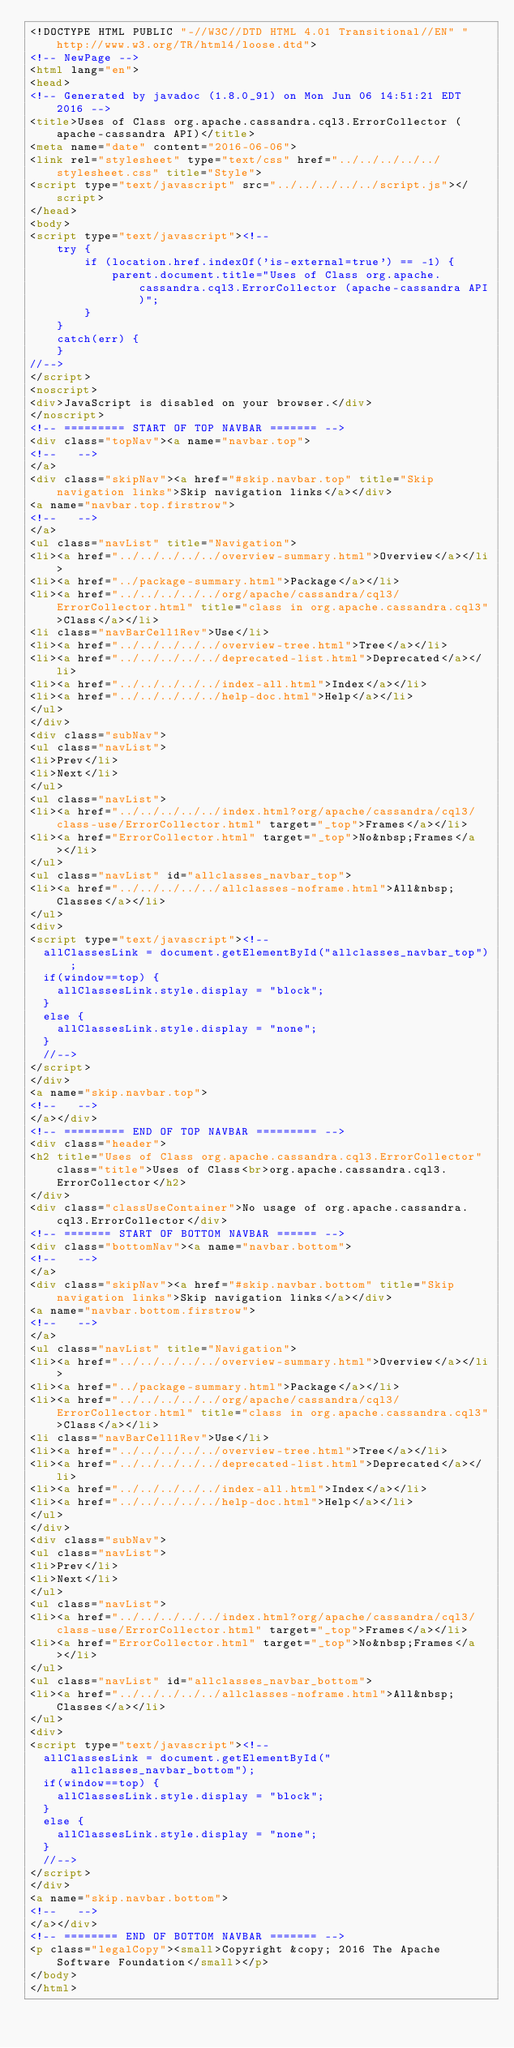Convert code to text. <code><loc_0><loc_0><loc_500><loc_500><_HTML_><!DOCTYPE HTML PUBLIC "-//W3C//DTD HTML 4.01 Transitional//EN" "http://www.w3.org/TR/html4/loose.dtd">
<!-- NewPage -->
<html lang="en">
<head>
<!-- Generated by javadoc (1.8.0_91) on Mon Jun 06 14:51:21 EDT 2016 -->
<title>Uses of Class org.apache.cassandra.cql3.ErrorCollector (apache-cassandra API)</title>
<meta name="date" content="2016-06-06">
<link rel="stylesheet" type="text/css" href="../../../../../stylesheet.css" title="Style">
<script type="text/javascript" src="../../../../../script.js"></script>
</head>
<body>
<script type="text/javascript"><!--
    try {
        if (location.href.indexOf('is-external=true') == -1) {
            parent.document.title="Uses of Class org.apache.cassandra.cql3.ErrorCollector (apache-cassandra API)";
        }
    }
    catch(err) {
    }
//-->
</script>
<noscript>
<div>JavaScript is disabled on your browser.</div>
</noscript>
<!-- ========= START OF TOP NAVBAR ======= -->
<div class="topNav"><a name="navbar.top">
<!--   -->
</a>
<div class="skipNav"><a href="#skip.navbar.top" title="Skip navigation links">Skip navigation links</a></div>
<a name="navbar.top.firstrow">
<!--   -->
</a>
<ul class="navList" title="Navigation">
<li><a href="../../../../../overview-summary.html">Overview</a></li>
<li><a href="../package-summary.html">Package</a></li>
<li><a href="../../../../../org/apache/cassandra/cql3/ErrorCollector.html" title="class in org.apache.cassandra.cql3">Class</a></li>
<li class="navBarCell1Rev">Use</li>
<li><a href="../../../../../overview-tree.html">Tree</a></li>
<li><a href="../../../../../deprecated-list.html">Deprecated</a></li>
<li><a href="../../../../../index-all.html">Index</a></li>
<li><a href="../../../../../help-doc.html">Help</a></li>
</ul>
</div>
<div class="subNav">
<ul class="navList">
<li>Prev</li>
<li>Next</li>
</ul>
<ul class="navList">
<li><a href="../../../../../index.html?org/apache/cassandra/cql3/class-use/ErrorCollector.html" target="_top">Frames</a></li>
<li><a href="ErrorCollector.html" target="_top">No&nbsp;Frames</a></li>
</ul>
<ul class="navList" id="allclasses_navbar_top">
<li><a href="../../../../../allclasses-noframe.html">All&nbsp;Classes</a></li>
</ul>
<div>
<script type="text/javascript"><!--
  allClassesLink = document.getElementById("allclasses_navbar_top");
  if(window==top) {
    allClassesLink.style.display = "block";
  }
  else {
    allClassesLink.style.display = "none";
  }
  //-->
</script>
</div>
<a name="skip.navbar.top">
<!--   -->
</a></div>
<!-- ========= END OF TOP NAVBAR ========= -->
<div class="header">
<h2 title="Uses of Class org.apache.cassandra.cql3.ErrorCollector" class="title">Uses of Class<br>org.apache.cassandra.cql3.ErrorCollector</h2>
</div>
<div class="classUseContainer">No usage of org.apache.cassandra.cql3.ErrorCollector</div>
<!-- ======= START OF BOTTOM NAVBAR ====== -->
<div class="bottomNav"><a name="navbar.bottom">
<!--   -->
</a>
<div class="skipNav"><a href="#skip.navbar.bottom" title="Skip navigation links">Skip navigation links</a></div>
<a name="navbar.bottom.firstrow">
<!--   -->
</a>
<ul class="navList" title="Navigation">
<li><a href="../../../../../overview-summary.html">Overview</a></li>
<li><a href="../package-summary.html">Package</a></li>
<li><a href="../../../../../org/apache/cassandra/cql3/ErrorCollector.html" title="class in org.apache.cassandra.cql3">Class</a></li>
<li class="navBarCell1Rev">Use</li>
<li><a href="../../../../../overview-tree.html">Tree</a></li>
<li><a href="../../../../../deprecated-list.html">Deprecated</a></li>
<li><a href="../../../../../index-all.html">Index</a></li>
<li><a href="../../../../../help-doc.html">Help</a></li>
</ul>
</div>
<div class="subNav">
<ul class="navList">
<li>Prev</li>
<li>Next</li>
</ul>
<ul class="navList">
<li><a href="../../../../../index.html?org/apache/cassandra/cql3/class-use/ErrorCollector.html" target="_top">Frames</a></li>
<li><a href="ErrorCollector.html" target="_top">No&nbsp;Frames</a></li>
</ul>
<ul class="navList" id="allclasses_navbar_bottom">
<li><a href="../../../../../allclasses-noframe.html">All&nbsp;Classes</a></li>
</ul>
<div>
<script type="text/javascript"><!--
  allClassesLink = document.getElementById("allclasses_navbar_bottom");
  if(window==top) {
    allClassesLink.style.display = "block";
  }
  else {
    allClassesLink.style.display = "none";
  }
  //-->
</script>
</div>
<a name="skip.navbar.bottom">
<!--   -->
</a></div>
<!-- ======== END OF BOTTOM NAVBAR ======= -->
<p class="legalCopy"><small>Copyright &copy; 2016 The Apache Software Foundation</small></p>
</body>
</html>
</code> 